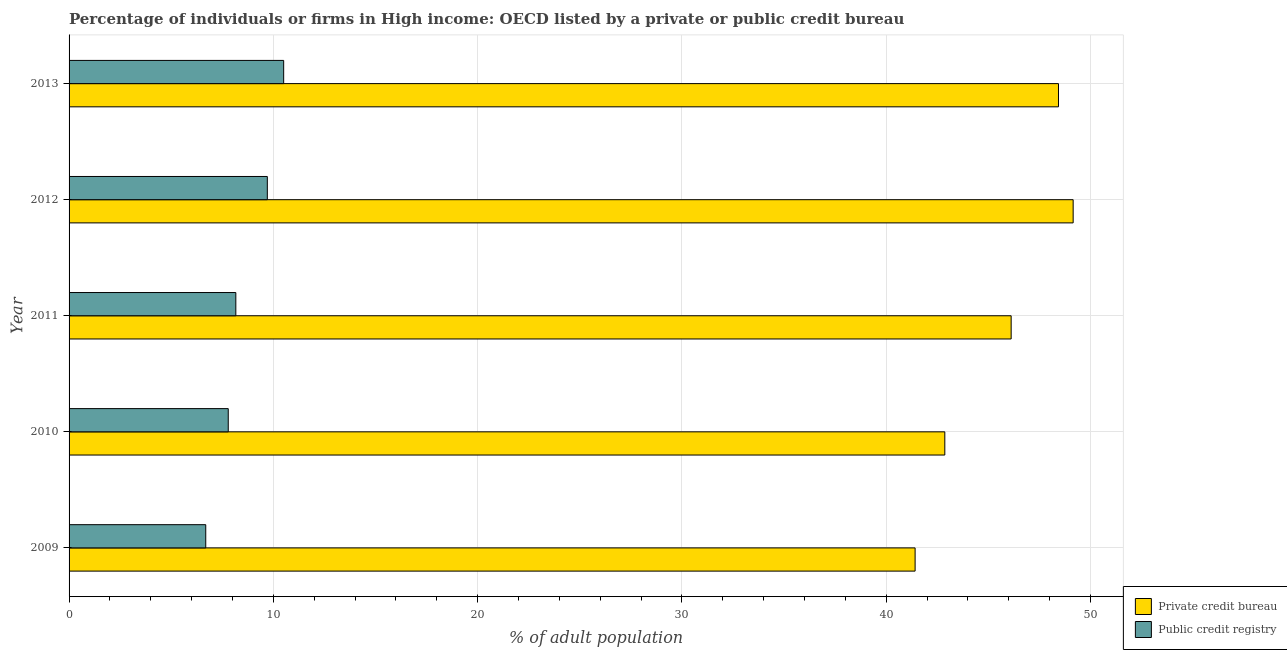How many different coloured bars are there?
Your answer should be very brief. 2. Are the number of bars on each tick of the Y-axis equal?
Provide a succinct answer. Yes. How many bars are there on the 3rd tick from the bottom?
Your response must be concise. 2. In how many cases, is the number of bars for a given year not equal to the number of legend labels?
Offer a very short reply. 0. What is the percentage of firms listed by public credit bureau in 2010?
Offer a terse response. 7.79. Across all years, what is the maximum percentage of firms listed by private credit bureau?
Offer a very short reply. 49.15. Across all years, what is the minimum percentage of firms listed by private credit bureau?
Make the answer very short. 41.42. In which year was the percentage of firms listed by private credit bureau minimum?
Keep it short and to the point. 2009. What is the total percentage of firms listed by private credit bureau in the graph?
Provide a succinct answer. 227.99. What is the difference between the percentage of firms listed by private credit bureau in 2009 and that in 2010?
Your response must be concise. -1.45. What is the difference between the percentage of firms listed by private credit bureau in 2009 and the percentage of firms listed by public credit bureau in 2010?
Make the answer very short. 33.62. What is the average percentage of firms listed by public credit bureau per year?
Your response must be concise. 8.57. In the year 2009, what is the difference between the percentage of firms listed by private credit bureau and percentage of firms listed by public credit bureau?
Provide a short and direct response. 34.73. What is the ratio of the percentage of firms listed by private credit bureau in 2009 to that in 2011?
Ensure brevity in your answer.  0.9. What is the difference between the highest and the second highest percentage of firms listed by private credit bureau?
Your answer should be very brief. 0.72. What is the difference between the highest and the lowest percentage of firms listed by private credit bureau?
Keep it short and to the point. 7.74. In how many years, is the percentage of firms listed by public credit bureau greater than the average percentage of firms listed by public credit bureau taken over all years?
Offer a terse response. 2. Is the sum of the percentage of firms listed by public credit bureau in 2011 and 2013 greater than the maximum percentage of firms listed by private credit bureau across all years?
Offer a terse response. No. What does the 1st bar from the top in 2013 represents?
Provide a succinct answer. Public credit registry. What does the 2nd bar from the bottom in 2013 represents?
Make the answer very short. Public credit registry. What is the difference between two consecutive major ticks on the X-axis?
Your response must be concise. 10. Does the graph contain grids?
Offer a very short reply. Yes. What is the title of the graph?
Keep it short and to the point. Percentage of individuals or firms in High income: OECD listed by a private or public credit bureau. Does "Female" appear as one of the legend labels in the graph?
Make the answer very short. No. What is the label or title of the X-axis?
Your answer should be compact. % of adult population. What is the % of adult population in Private credit bureau in 2009?
Offer a very short reply. 41.42. What is the % of adult population in Public credit registry in 2009?
Offer a very short reply. 6.69. What is the % of adult population of Private credit bureau in 2010?
Provide a short and direct response. 42.87. What is the % of adult population in Public credit registry in 2010?
Make the answer very short. 7.79. What is the % of adult population in Private credit bureau in 2011?
Keep it short and to the point. 46.12. What is the % of adult population of Public credit registry in 2011?
Offer a terse response. 8.16. What is the % of adult population of Private credit bureau in 2012?
Your response must be concise. 49.15. What is the % of adult population in Public credit registry in 2012?
Give a very brief answer. 9.71. What is the % of adult population of Private credit bureau in 2013?
Provide a succinct answer. 48.44. What is the % of adult population of Public credit registry in 2013?
Your response must be concise. 10.51. Across all years, what is the maximum % of adult population of Private credit bureau?
Ensure brevity in your answer.  49.15. Across all years, what is the maximum % of adult population in Public credit registry?
Offer a terse response. 10.51. Across all years, what is the minimum % of adult population of Private credit bureau?
Your answer should be very brief. 41.42. Across all years, what is the minimum % of adult population of Public credit registry?
Ensure brevity in your answer.  6.69. What is the total % of adult population in Private credit bureau in the graph?
Keep it short and to the point. 227.99. What is the total % of adult population in Public credit registry in the graph?
Your response must be concise. 42.86. What is the difference between the % of adult population of Private credit bureau in 2009 and that in 2010?
Ensure brevity in your answer.  -1.45. What is the difference between the % of adult population in Public credit registry in 2009 and that in 2010?
Provide a short and direct response. -1.1. What is the difference between the % of adult population of Private credit bureau in 2009 and that in 2011?
Give a very brief answer. -4.7. What is the difference between the % of adult population in Public credit registry in 2009 and that in 2011?
Make the answer very short. -1.47. What is the difference between the % of adult population in Private credit bureau in 2009 and that in 2012?
Give a very brief answer. -7.74. What is the difference between the % of adult population of Public credit registry in 2009 and that in 2012?
Your answer should be compact. -3.01. What is the difference between the % of adult population of Private credit bureau in 2009 and that in 2013?
Your answer should be compact. -7.02. What is the difference between the % of adult population of Public credit registry in 2009 and that in 2013?
Give a very brief answer. -3.81. What is the difference between the % of adult population of Private credit bureau in 2010 and that in 2011?
Provide a short and direct response. -3.25. What is the difference between the % of adult population in Public credit registry in 2010 and that in 2011?
Give a very brief answer. -0.37. What is the difference between the % of adult population of Private credit bureau in 2010 and that in 2012?
Provide a short and direct response. -6.28. What is the difference between the % of adult population of Public credit registry in 2010 and that in 2012?
Give a very brief answer. -1.91. What is the difference between the % of adult population in Private credit bureau in 2010 and that in 2013?
Ensure brevity in your answer.  -5.56. What is the difference between the % of adult population of Public credit registry in 2010 and that in 2013?
Your response must be concise. -2.71. What is the difference between the % of adult population in Private credit bureau in 2011 and that in 2012?
Offer a terse response. -3.04. What is the difference between the % of adult population of Public credit registry in 2011 and that in 2012?
Make the answer very short. -1.54. What is the difference between the % of adult population of Private credit bureau in 2011 and that in 2013?
Provide a short and direct response. -2.32. What is the difference between the % of adult population of Public credit registry in 2011 and that in 2013?
Ensure brevity in your answer.  -2.34. What is the difference between the % of adult population in Private credit bureau in 2012 and that in 2013?
Your answer should be very brief. 0.72. What is the difference between the % of adult population in Public credit registry in 2012 and that in 2013?
Your answer should be very brief. -0.8. What is the difference between the % of adult population in Private credit bureau in 2009 and the % of adult population in Public credit registry in 2010?
Make the answer very short. 33.62. What is the difference between the % of adult population of Private credit bureau in 2009 and the % of adult population of Public credit registry in 2011?
Your response must be concise. 33.25. What is the difference between the % of adult population in Private credit bureau in 2009 and the % of adult population in Public credit registry in 2012?
Your response must be concise. 31.71. What is the difference between the % of adult population in Private credit bureau in 2009 and the % of adult population in Public credit registry in 2013?
Provide a short and direct response. 30.91. What is the difference between the % of adult population of Private credit bureau in 2010 and the % of adult population of Public credit registry in 2011?
Your answer should be very brief. 34.71. What is the difference between the % of adult population in Private credit bureau in 2010 and the % of adult population in Public credit registry in 2012?
Provide a short and direct response. 33.16. What is the difference between the % of adult population of Private credit bureau in 2010 and the % of adult population of Public credit registry in 2013?
Offer a very short reply. 32.37. What is the difference between the % of adult population of Private credit bureau in 2011 and the % of adult population of Public credit registry in 2012?
Provide a short and direct response. 36.41. What is the difference between the % of adult population of Private credit bureau in 2011 and the % of adult population of Public credit registry in 2013?
Make the answer very short. 35.61. What is the difference between the % of adult population in Private credit bureau in 2012 and the % of adult population in Public credit registry in 2013?
Your response must be concise. 38.65. What is the average % of adult population of Private credit bureau per year?
Ensure brevity in your answer.  45.6. What is the average % of adult population in Public credit registry per year?
Offer a terse response. 8.57. In the year 2009, what is the difference between the % of adult population of Private credit bureau and % of adult population of Public credit registry?
Keep it short and to the point. 34.73. In the year 2010, what is the difference between the % of adult population of Private credit bureau and % of adult population of Public credit registry?
Your response must be concise. 35.08. In the year 2011, what is the difference between the % of adult population of Private credit bureau and % of adult population of Public credit registry?
Keep it short and to the point. 37.96. In the year 2012, what is the difference between the % of adult population in Private credit bureau and % of adult population in Public credit registry?
Give a very brief answer. 39.45. In the year 2013, what is the difference between the % of adult population in Private credit bureau and % of adult population in Public credit registry?
Provide a succinct answer. 37.93. What is the ratio of the % of adult population in Private credit bureau in 2009 to that in 2010?
Offer a terse response. 0.97. What is the ratio of the % of adult population in Public credit registry in 2009 to that in 2010?
Ensure brevity in your answer.  0.86. What is the ratio of the % of adult population of Private credit bureau in 2009 to that in 2011?
Your answer should be very brief. 0.9. What is the ratio of the % of adult population of Public credit registry in 2009 to that in 2011?
Provide a short and direct response. 0.82. What is the ratio of the % of adult population in Private credit bureau in 2009 to that in 2012?
Your answer should be very brief. 0.84. What is the ratio of the % of adult population of Public credit registry in 2009 to that in 2012?
Make the answer very short. 0.69. What is the ratio of the % of adult population in Private credit bureau in 2009 to that in 2013?
Your answer should be very brief. 0.86. What is the ratio of the % of adult population of Public credit registry in 2009 to that in 2013?
Make the answer very short. 0.64. What is the ratio of the % of adult population in Private credit bureau in 2010 to that in 2011?
Make the answer very short. 0.93. What is the ratio of the % of adult population of Public credit registry in 2010 to that in 2011?
Your answer should be very brief. 0.95. What is the ratio of the % of adult population in Private credit bureau in 2010 to that in 2012?
Give a very brief answer. 0.87. What is the ratio of the % of adult population of Public credit registry in 2010 to that in 2012?
Your response must be concise. 0.8. What is the ratio of the % of adult population of Private credit bureau in 2010 to that in 2013?
Make the answer very short. 0.89. What is the ratio of the % of adult population in Public credit registry in 2010 to that in 2013?
Offer a very short reply. 0.74. What is the ratio of the % of adult population of Private credit bureau in 2011 to that in 2012?
Ensure brevity in your answer.  0.94. What is the ratio of the % of adult population of Public credit registry in 2011 to that in 2012?
Give a very brief answer. 0.84. What is the ratio of the % of adult population of Private credit bureau in 2011 to that in 2013?
Your answer should be compact. 0.95. What is the ratio of the % of adult population of Public credit registry in 2011 to that in 2013?
Ensure brevity in your answer.  0.78. What is the ratio of the % of adult population of Private credit bureau in 2012 to that in 2013?
Make the answer very short. 1.01. What is the ratio of the % of adult population in Public credit registry in 2012 to that in 2013?
Keep it short and to the point. 0.92. What is the difference between the highest and the second highest % of adult population in Private credit bureau?
Provide a succinct answer. 0.72. What is the difference between the highest and the second highest % of adult population of Public credit registry?
Offer a very short reply. 0.8. What is the difference between the highest and the lowest % of adult population in Private credit bureau?
Give a very brief answer. 7.74. What is the difference between the highest and the lowest % of adult population of Public credit registry?
Make the answer very short. 3.81. 